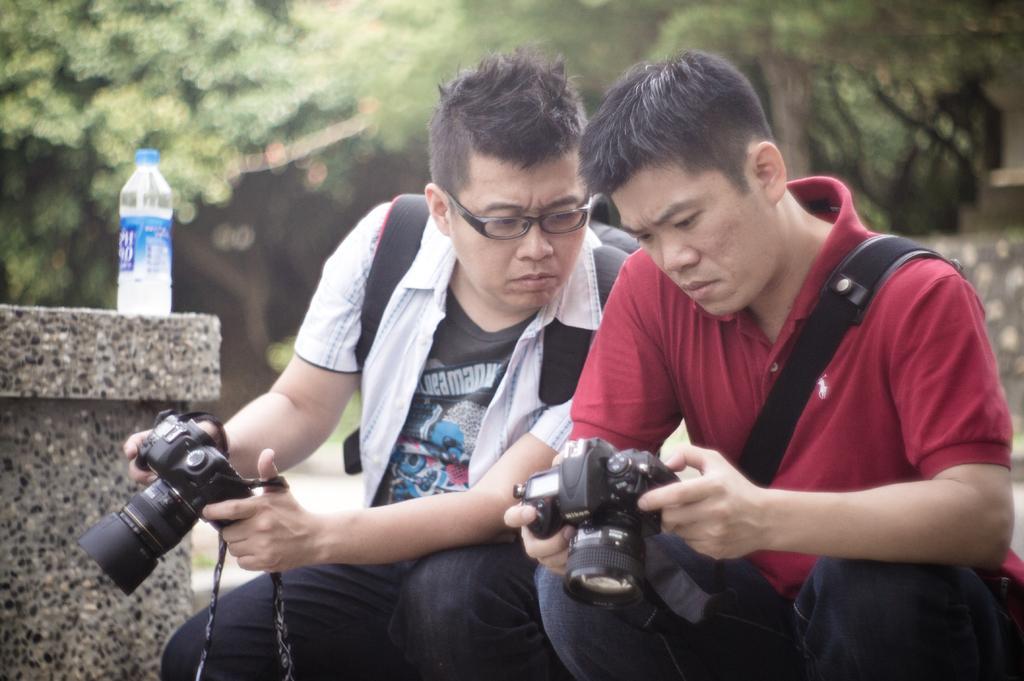In one or two sentences, can you explain what this image depicts? On the background we can see trees. here we can see two men sitting and holding cameras in their hands. Both men are starting to this camera. This man wore spectacles. We can see bottle here. 